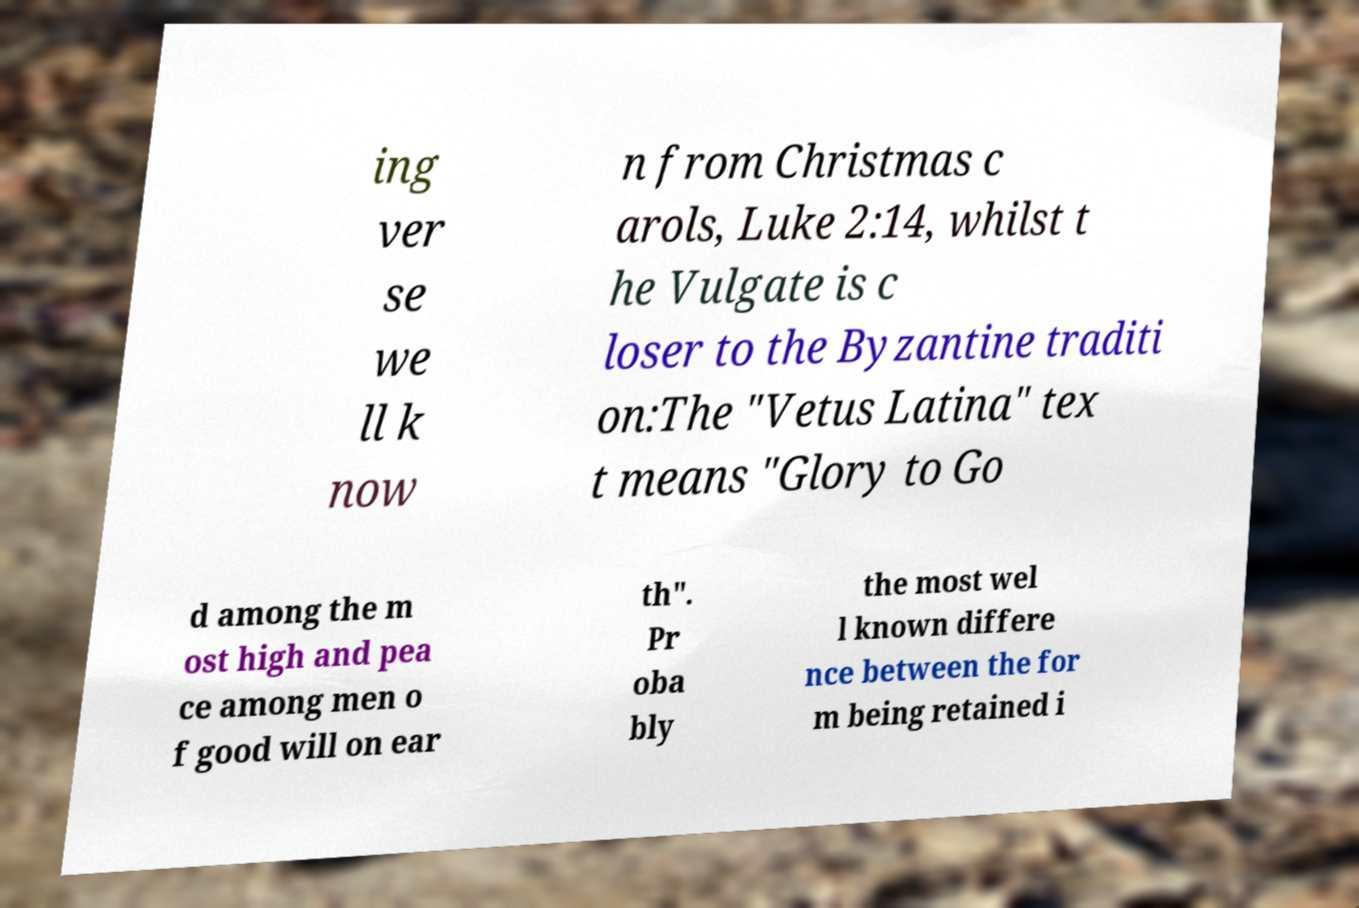I need the written content from this picture converted into text. Can you do that? ing ver se we ll k now n from Christmas c arols, Luke 2:14, whilst t he Vulgate is c loser to the Byzantine traditi on:The "Vetus Latina" tex t means "Glory to Go d among the m ost high and pea ce among men o f good will on ear th". Pr oba bly the most wel l known differe nce between the for m being retained i 